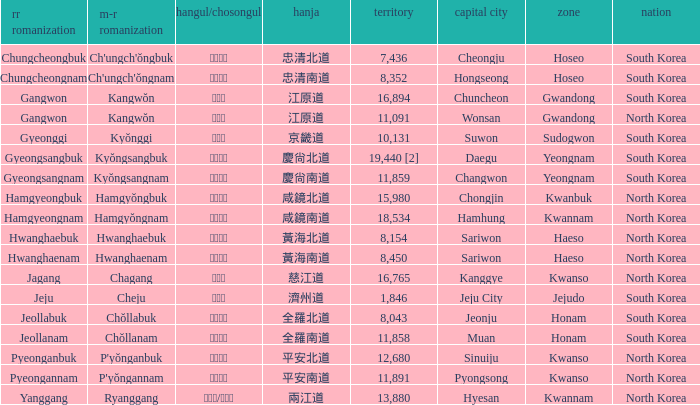What is the area for the province having Hangul of 경기도? 10131.0. 